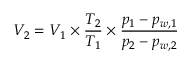<formula> <loc_0><loc_0><loc_500><loc_500>V _ { 2 } = V _ { 1 } \times { \frac { T _ { 2 } } { T _ { 1 } } } \times { \frac { p _ { 1 } - p _ { w , 1 } } { p _ { 2 } - p _ { w , 2 } } }</formula> 